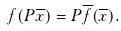<formula> <loc_0><loc_0><loc_500><loc_500>f ( P \overline { x } ) = P \overline { f } ( \overline { x } ) .</formula> 